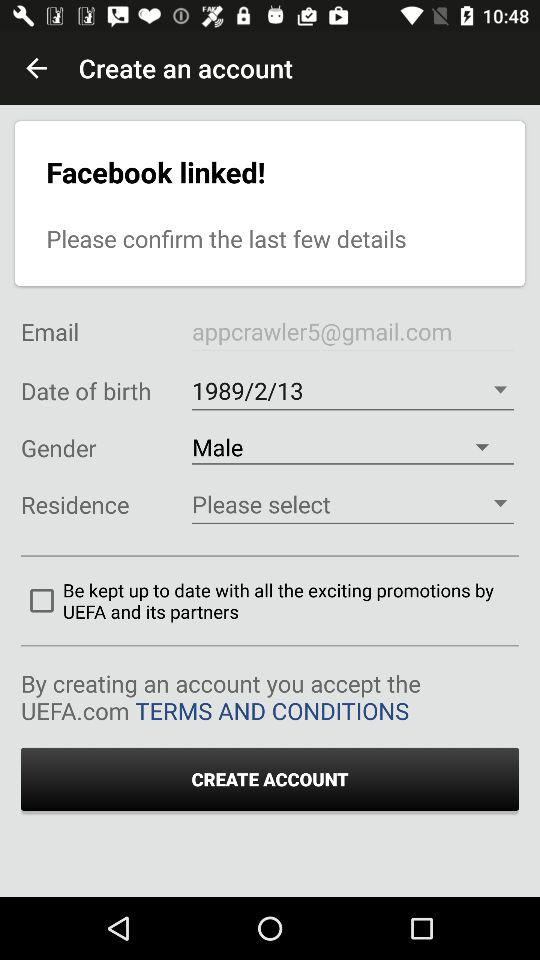What is the status of "Be kept up to date with all the exciting promotions by UEFA"? The status is "off". 